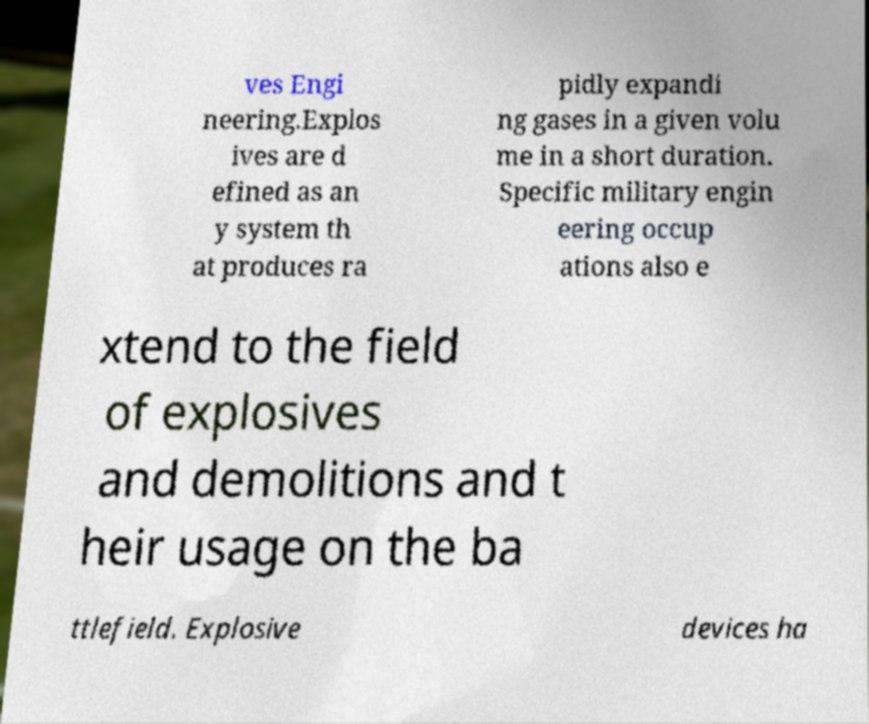Can you accurately transcribe the text from the provided image for me? ves Engi neering.Explos ives are d efined as an y system th at produces ra pidly expandi ng gases in a given volu me in a short duration. Specific military engin eering occup ations also e xtend to the field of explosives and demolitions and t heir usage on the ba ttlefield. Explosive devices ha 